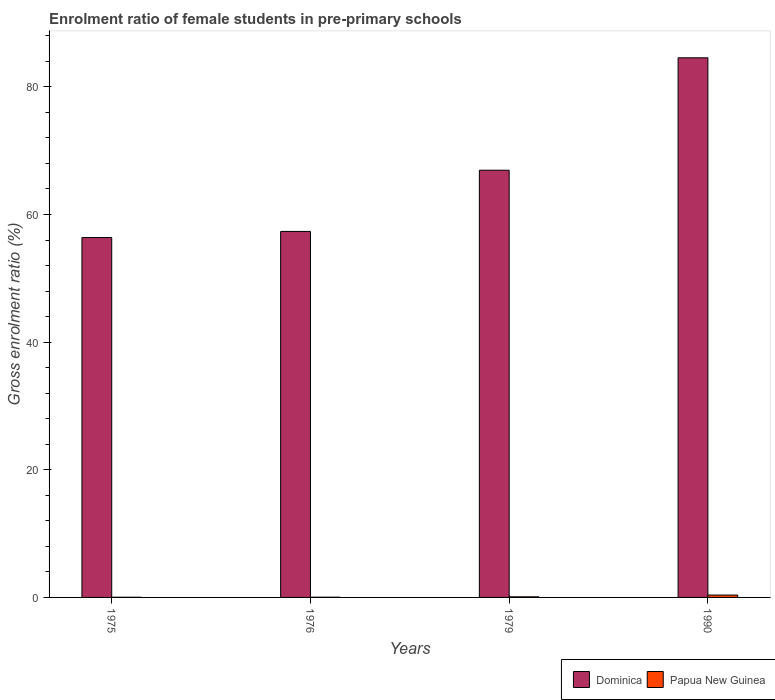How many different coloured bars are there?
Your response must be concise. 2. How many groups of bars are there?
Ensure brevity in your answer.  4. Are the number of bars per tick equal to the number of legend labels?
Give a very brief answer. Yes. Are the number of bars on each tick of the X-axis equal?
Provide a short and direct response. Yes. How many bars are there on the 4th tick from the left?
Offer a very short reply. 2. How many bars are there on the 1st tick from the right?
Offer a terse response. 2. What is the label of the 3rd group of bars from the left?
Ensure brevity in your answer.  1979. What is the enrolment ratio of female students in pre-primary schools in Dominica in 1990?
Keep it short and to the point. 84.55. Across all years, what is the maximum enrolment ratio of female students in pre-primary schools in Papua New Guinea?
Give a very brief answer. 0.37. Across all years, what is the minimum enrolment ratio of female students in pre-primary schools in Papua New Guinea?
Your response must be concise. 0.03. In which year was the enrolment ratio of female students in pre-primary schools in Papua New Guinea minimum?
Your response must be concise. 1975. What is the total enrolment ratio of female students in pre-primary schools in Papua New Guinea in the graph?
Offer a terse response. 0.53. What is the difference between the enrolment ratio of female students in pre-primary schools in Dominica in 1975 and that in 1976?
Your response must be concise. -0.96. What is the difference between the enrolment ratio of female students in pre-primary schools in Papua New Guinea in 1979 and the enrolment ratio of female students in pre-primary schools in Dominica in 1990?
Offer a very short reply. -84.45. What is the average enrolment ratio of female students in pre-primary schools in Dominica per year?
Give a very brief answer. 66.3. In the year 1990, what is the difference between the enrolment ratio of female students in pre-primary schools in Papua New Guinea and enrolment ratio of female students in pre-primary schools in Dominica?
Offer a terse response. -84.18. What is the ratio of the enrolment ratio of female students in pre-primary schools in Dominica in 1975 to that in 1976?
Offer a terse response. 0.98. Is the enrolment ratio of female students in pre-primary schools in Dominica in 1975 less than that in 1976?
Make the answer very short. Yes. Is the difference between the enrolment ratio of female students in pre-primary schools in Papua New Guinea in 1976 and 1979 greater than the difference between the enrolment ratio of female students in pre-primary schools in Dominica in 1976 and 1979?
Ensure brevity in your answer.  Yes. What is the difference between the highest and the second highest enrolment ratio of female students in pre-primary schools in Dominica?
Your answer should be compact. 17.62. What is the difference between the highest and the lowest enrolment ratio of female students in pre-primary schools in Papua New Guinea?
Keep it short and to the point. 0.35. Is the sum of the enrolment ratio of female students in pre-primary schools in Papua New Guinea in 1979 and 1990 greater than the maximum enrolment ratio of female students in pre-primary schools in Dominica across all years?
Give a very brief answer. No. What does the 1st bar from the left in 1979 represents?
Your response must be concise. Dominica. What does the 1st bar from the right in 1975 represents?
Give a very brief answer. Papua New Guinea. Are all the bars in the graph horizontal?
Provide a succinct answer. No. How many years are there in the graph?
Your response must be concise. 4. Where does the legend appear in the graph?
Your answer should be very brief. Bottom right. How are the legend labels stacked?
Ensure brevity in your answer.  Horizontal. What is the title of the graph?
Your answer should be compact. Enrolment ratio of female students in pre-primary schools. Does "Nepal" appear as one of the legend labels in the graph?
Your answer should be very brief. No. What is the label or title of the X-axis?
Make the answer very short. Years. What is the label or title of the Y-axis?
Give a very brief answer. Gross enrolment ratio (%). What is the Gross enrolment ratio (%) of Dominica in 1975?
Give a very brief answer. 56.39. What is the Gross enrolment ratio (%) in Papua New Guinea in 1975?
Ensure brevity in your answer.  0.03. What is the Gross enrolment ratio (%) of Dominica in 1976?
Give a very brief answer. 57.34. What is the Gross enrolment ratio (%) of Papua New Guinea in 1976?
Make the answer very short. 0.04. What is the Gross enrolment ratio (%) of Dominica in 1979?
Ensure brevity in your answer.  66.93. What is the Gross enrolment ratio (%) in Papua New Guinea in 1979?
Offer a very short reply. 0.1. What is the Gross enrolment ratio (%) of Dominica in 1990?
Provide a short and direct response. 84.55. What is the Gross enrolment ratio (%) in Papua New Guinea in 1990?
Offer a very short reply. 0.37. Across all years, what is the maximum Gross enrolment ratio (%) of Dominica?
Make the answer very short. 84.55. Across all years, what is the maximum Gross enrolment ratio (%) of Papua New Guinea?
Your response must be concise. 0.37. Across all years, what is the minimum Gross enrolment ratio (%) of Dominica?
Keep it short and to the point. 56.39. Across all years, what is the minimum Gross enrolment ratio (%) in Papua New Guinea?
Ensure brevity in your answer.  0.03. What is the total Gross enrolment ratio (%) of Dominica in the graph?
Provide a short and direct response. 265.21. What is the total Gross enrolment ratio (%) of Papua New Guinea in the graph?
Ensure brevity in your answer.  0.53. What is the difference between the Gross enrolment ratio (%) in Dominica in 1975 and that in 1976?
Provide a succinct answer. -0.96. What is the difference between the Gross enrolment ratio (%) of Papua New Guinea in 1975 and that in 1976?
Provide a short and direct response. -0.01. What is the difference between the Gross enrolment ratio (%) in Dominica in 1975 and that in 1979?
Offer a very short reply. -10.55. What is the difference between the Gross enrolment ratio (%) of Papua New Guinea in 1975 and that in 1979?
Your response must be concise. -0.07. What is the difference between the Gross enrolment ratio (%) of Dominica in 1975 and that in 1990?
Provide a succinct answer. -28.16. What is the difference between the Gross enrolment ratio (%) in Papua New Guinea in 1975 and that in 1990?
Offer a very short reply. -0.35. What is the difference between the Gross enrolment ratio (%) in Dominica in 1976 and that in 1979?
Provide a succinct answer. -9.59. What is the difference between the Gross enrolment ratio (%) in Papua New Guinea in 1976 and that in 1979?
Your answer should be compact. -0.06. What is the difference between the Gross enrolment ratio (%) of Dominica in 1976 and that in 1990?
Your answer should be compact. -27.2. What is the difference between the Gross enrolment ratio (%) in Papua New Guinea in 1976 and that in 1990?
Ensure brevity in your answer.  -0.34. What is the difference between the Gross enrolment ratio (%) in Dominica in 1979 and that in 1990?
Your response must be concise. -17.62. What is the difference between the Gross enrolment ratio (%) in Papua New Guinea in 1979 and that in 1990?
Give a very brief answer. -0.28. What is the difference between the Gross enrolment ratio (%) in Dominica in 1975 and the Gross enrolment ratio (%) in Papua New Guinea in 1976?
Ensure brevity in your answer.  56.35. What is the difference between the Gross enrolment ratio (%) of Dominica in 1975 and the Gross enrolment ratio (%) of Papua New Guinea in 1979?
Your answer should be compact. 56.29. What is the difference between the Gross enrolment ratio (%) in Dominica in 1975 and the Gross enrolment ratio (%) in Papua New Guinea in 1990?
Provide a succinct answer. 56.01. What is the difference between the Gross enrolment ratio (%) in Dominica in 1976 and the Gross enrolment ratio (%) in Papua New Guinea in 1979?
Your response must be concise. 57.25. What is the difference between the Gross enrolment ratio (%) in Dominica in 1976 and the Gross enrolment ratio (%) in Papua New Guinea in 1990?
Offer a very short reply. 56.97. What is the difference between the Gross enrolment ratio (%) in Dominica in 1979 and the Gross enrolment ratio (%) in Papua New Guinea in 1990?
Offer a very short reply. 66.56. What is the average Gross enrolment ratio (%) in Dominica per year?
Your answer should be very brief. 66.3. What is the average Gross enrolment ratio (%) of Papua New Guinea per year?
Give a very brief answer. 0.13. In the year 1975, what is the difference between the Gross enrolment ratio (%) of Dominica and Gross enrolment ratio (%) of Papua New Guinea?
Your answer should be very brief. 56.36. In the year 1976, what is the difference between the Gross enrolment ratio (%) of Dominica and Gross enrolment ratio (%) of Papua New Guinea?
Keep it short and to the point. 57.31. In the year 1979, what is the difference between the Gross enrolment ratio (%) in Dominica and Gross enrolment ratio (%) in Papua New Guinea?
Your answer should be very brief. 66.84. In the year 1990, what is the difference between the Gross enrolment ratio (%) in Dominica and Gross enrolment ratio (%) in Papua New Guinea?
Offer a terse response. 84.18. What is the ratio of the Gross enrolment ratio (%) of Dominica in 1975 to that in 1976?
Your answer should be very brief. 0.98. What is the ratio of the Gross enrolment ratio (%) in Papua New Guinea in 1975 to that in 1976?
Offer a very short reply. 0.69. What is the ratio of the Gross enrolment ratio (%) in Dominica in 1975 to that in 1979?
Ensure brevity in your answer.  0.84. What is the ratio of the Gross enrolment ratio (%) in Papua New Guinea in 1975 to that in 1979?
Offer a very short reply. 0.27. What is the ratio of the Gross enrolment ratio (%) in Dominica in 1975 to that in 1990?
Provide a short and direct response. 0.67. What is the ratio of the Gross enrolment ratio (%) of Papua New Guinea in 1975 to that in 1990?
Offer a terse response. 0.07. What is the ratio of the Gross enrolment ratio (%) in Dominica in 1976 to that in 1979?
Ensure brevity in your answer.  0.86. What is the ratio of the Gross enrolment ratio (%) of Papua New Guinea in 1976 to that in 1979?
Your answer should be very brief. 0.39. What is the ratio of the Gross enrolment ratio (%) of Dominica in 1976 to that in 1990?
Ensure brevity in your answer.  0.68. What is the ratio of the Gross enrolment ratio (%) of Papua New Guinea in 1976 to that in 1990?
Offer a very short reply. 0.1. What is the ratio of the Gross enrolment ratio (%) in Dominica in 1979 to that in 1990?
Ensure brevity in your answer.  0.79. What is the ratio of the Gross enrolment ratio (%) in Papua New Guinea in 1979 to that in 1990?
Keep it short and to the point. 0.26. What is the difference between the highest and the second highest Gross enrolment ratio (%) of Dominica?
Ensure brevity in your answer.  17.62. What is the difference between the highest and the second highest Gross enrolment ratio (%) in Papua New Guinea?
Your answer should be very brief. 0.28. What is the difference between the highest and the lowest Gross enrolment ratio (%) of Dominica?
Offer a very short reply. 28.16. What is the difference between the highest and the lowest Gross enrolment ratio (%) in Papua New Guinea?
Offer a very short reply. 0.35. 